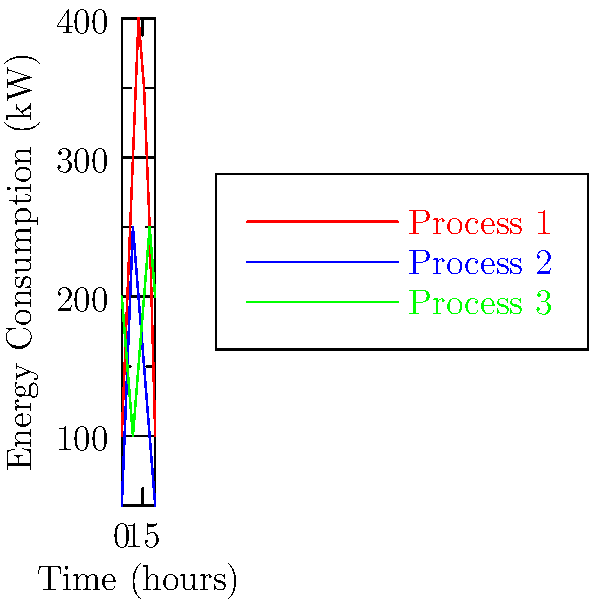Analyze the load profile chart showing energy consumption patterns of three industrial processes over a 24-hour period. Which process exhibits the highest peak-to-valley ratio, and what implications does this have for electrical system design and energy management in an industrial setting? To answer this question, we need to follow these steps:

1. Understand the peak-to-valley ratio:
   The peak-to-valley ratio is the ratio of the maximum power demand to the minimum power demand over a given period.

2. Identify the peak and valley for each process:
   Process 1: Peak = 400 kW, Valley = 100 kW
   Process 2: Peak = 250 kW, Valley = 50 kW
   Process 3: Peak = 250 kW, Valley = 100 kW

3. Calculate the peak-to-valley ratio for each process:
   Process 1: 400/100 = 4
   Process 2: 250/50 = 5
   Process 3: 250/100 = 2.5

4. Compare the ratios:
   Process 2 has the highest peak-to-valley ratio of 5.

5. Implications for electrical system design and energy management:
   a) Higher capacity requirements: The electrical system must be designed to handle the peak load, even if it occurs for a short duration.
   b) Increased costs: Larger transformers, switchgear, and distribution equipment are needed to accommodate the peak demand.
   c) Lower load factor: This leads to inefficient use of electrical infrastructure and potentially higher electricity costs.
   d) Demand charges: Many utilities impose demand charges based on peak power consumption, which can significantly impact electricity bills.
   e) Energy storage potential: There may be opportunities to implement energy storage systems to reduce peak demand and improve overall system efficiency.
   f) Load shifting: Identifying opportunities to shift some of the load to off-peak hours could help optimize energy consumption and reduce costs.
   g) Power quality concerns: Large variations in power demand may lead to voltage fluctuations and other power quality issues.
Answer: Process 2; highest peak-to-valley ratio (5) implies need for larger capacity infrastructure, potential for higher costs, and opportunities for load management strategies. 